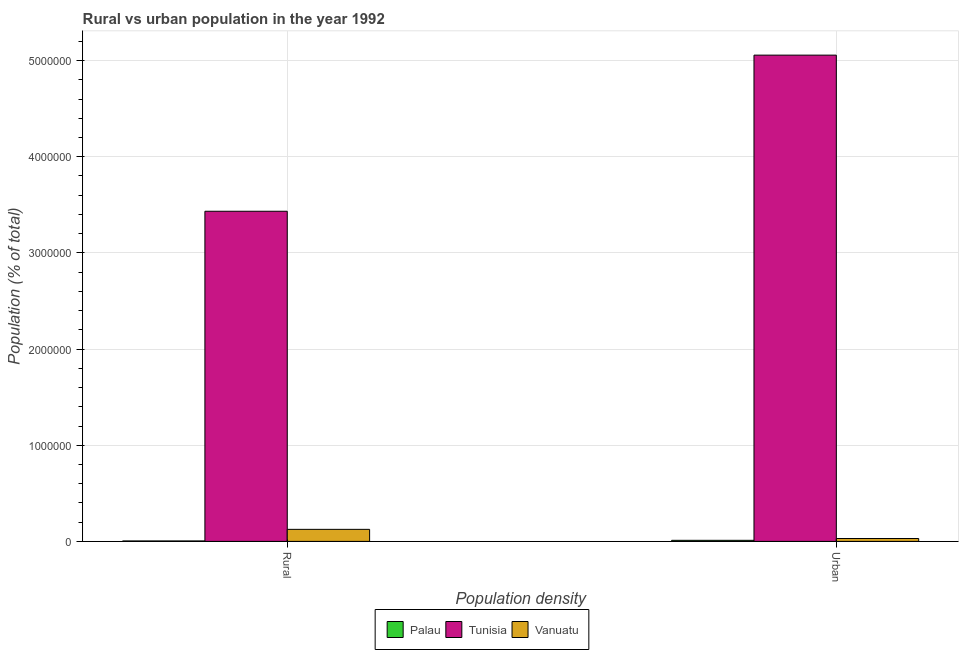How many different coloured bars are there?
Offer a terse response. 3. Are the number of bars on each tick of the X-axis equal?
Your answer should be very brief. Yes. What is the label of the 2nd group of bars from the left?
Ensure brevity in your answer.  Urban. What is the urban population density in Palau?
Your answer should be compact. 1.12e+04. Across all countries, what is the maximum rural population density?
Provide a short and direct response. 3.43e+06. Across all countries, what is the minimum rural population density?
Keep it short and to the point. 4715. In which country was the rural population density maximum?
Ensure brevity in your answer.  Tunisia. In which country was the rural population density minimum?
Make the answer very short. Palau. What is the total urban population density in the graph?
Ensure brevity in your answer.  5.10e+06. What is the difference between the urban population density in Vanuatu and that in Tunisia?
Your response must be concise. -5.03e+06. What is the difference between the rural population density in Tunisia and the urban population density in Vanuatu?
Give a very brief answer. 3.40e+06. What is the average rural population density per country?
Ensure brevity in your answer.  1.19e+06. What is the difference between the rural population density and urban population density in Palau?
Provide a succinct answer. -6464. What is the ratio of the urban population density in Tunisia to that in Vanuatu?
Your response must be concise. 168.91. What does the 3rd bar from the left in Rural represents?
Ensure brevity in your answer.  Vanuatu. What does the 3rd bar from the right in Rural represents?
Your answer should be very brief. Palau. How many bars are there?
Give a very brief answer. 6. What is the difference between two consecutive major ticks on the Y-axis?
Keep it short and to the point. 1.00e+06. Are the values on the major ticks of Y-axis written in scientific E-notation?
Offer a very short reply. No. How are the legend labels stacked?
Your response must be concise. Horizontal. What is the title of the graph?
Make the answer very short. Rural vs urban population in the year 1992. Does "Slovak Republic" appear as one of the legend labels in the graph?
Your answer should be very brief. No. What is the label or title of the X-axis?
Ensure brevity in your answer.  Population density. What is the label or title of the Y-axis?
Your response must be concise. Population (% of total). What is the Population (% of total) in Palau in Rural?
Provide a short and direct response. 4715. What is the Population (% of total) of Tunisia in Rural?
Make the answer very short. 3.43e+06. What is the Population (% of total) in Vanuatu in Rural?
Provide a short and direct response. 1.25e+05. What is the Population (% of total) in Palau in Urban?
Your response must be concise. 1.12e+04. What is the Population (% of total) in Tunisia in Urban?
Your answer should be compact. 5.06e+06. What is the Population (% of total) in Vanuatu in Urban?
Offer a terse response. 2.99e+04. Across all Population density, what is the maximum Population (% of total) in Palau?
Your response must be concise. 1.12e+04. Across all Population density, what is the maximum Population (% of total) of Tunisia?
Offer a terse response. 5.06e+06. Across all Population density, what is the maximum Population (% of total) of Vanuatu?
Ensure brevity in your answer.  1.25e+05. Across all Population density, what is the minimum Population (% of total) in Palau?
Your answer should be very brief. 4715. Across all Population density, what is the minimum Population (% of total) of Tunisia?
Ensure brevity in your answer.  3.43e+06. Across all Population density, what is the minimum Population (% of total) in Vanuatu?
Ensure brevity in your answer.  2.99e+04. What is the total Population (% of total) in Palau in the graph?
Offer a terse response. 1.59e+04. What is the total Population (% of total) of Tunisia in the graph?
Provide a succinct answer. 8.49e+06. What is the total Population (% of total) in Vanuatu in the graph?
Ensure brevity in your answer.  1.55e+05. What is the difference between the Population (% of total) of Palau in Rural and that in Urban?
Keep it short and to the point. -6464. What is the difference between the Population (% of total) in Tunisia in Rural and that in Urban?
Provide a succinct answer. -1.62e+06. What is the difference between the Population (% of total) of Vanuatu in Rural and that in Urban?
Keep it short and to the point. 9.54e+04. What is the difference between the Population (% of total) of Palau in Rural and the Population (% of total) of Tunisia in Urban?
Your response must be concise. -5.05e+06. What is the difference between the Population (% of total) of Palau in Rural and the Population (% of total) of Vanuatu in Urban?
Provide a succinct answer. -2.52e+04. What is the difference between the Population (% of total) of Tunisia in Rural and the Population (% of total) of Vanuatu in Urban?
Your answer should be compact. 3.40e+06. What is the average Population (% of total) of Palau per Population density?
Provide a short and direct response. 7947. What is the average Population (% of total) in Tunisia per Population density?
Make the answer very short. 4.24e+06. What is the average Population (% of total) of Vanuatu per Population density?
Your answer should be very brief. 7.76e+04. What is the difference between the Population (% of total) of Palau and Population (% of total) of Tunisia in Rural?
Offer a very short reply. -3.43e+06. What is the difference between the Population (% of total) in Palau and Population (% of total) in Vanuatu in Rural?
Make the answer very short. -1.21e+05. What is the difference between the Population (% of total) of Tunisia and Population (% of total) of Vanuatu in Rural?
Give a very brief answer. 3.31e+06. What is the difference between the Population (% of total) of Palau and Population (% of total) of Tunisia in Urban?
Provide a short and direct response. -5.05e+06. What is the difference between the Population (% of total) of Palau and Population (% of total) of Vanuatu in Urban?
Make the answer very short. -1.88e+04. What is the difference between the Population (% of total) in Tunisia and Population (% of total) in Vanuatu in Urban?
Offer a very short reply. 5.03e+06. What is the ratio of the Population (% of total) of Palau in Rural to that in Urban?
Your response must be concise. 0.42. What is the ratio of the Population (% of total) of Tunisia in Rural to that in Urban?
Give a very brief answer. 0.68. What is the ratio of the Population (% of total) of Vanuatu in Rural to that in Urban?
Provide a succinct answer. 4.19. What is the difference between the highest and the second highest Population (% of total) of Palau?
Offer a very short reply. 6464. What is the difference between the highest and the second highest Population (% of total) in Tunisia?
Offer a very short reply. 1.62e+06. What is the difference between the highest and the second highest Population (% of total) in Vanuatu?
Your answer should be compact. 9.54e+04. What is the difference between the highest and the lowest Population (% of total) of Palau?
Your response must be concise. 6464. What is the difference between the highest and the lowest Population (% of total) of Tunisia?
Offer a terse response. 1.62e+06. What is the difference between the highest and the lowest Population (% of total) in Vanuatu?
Your response must be concise. 9.54e+04. 